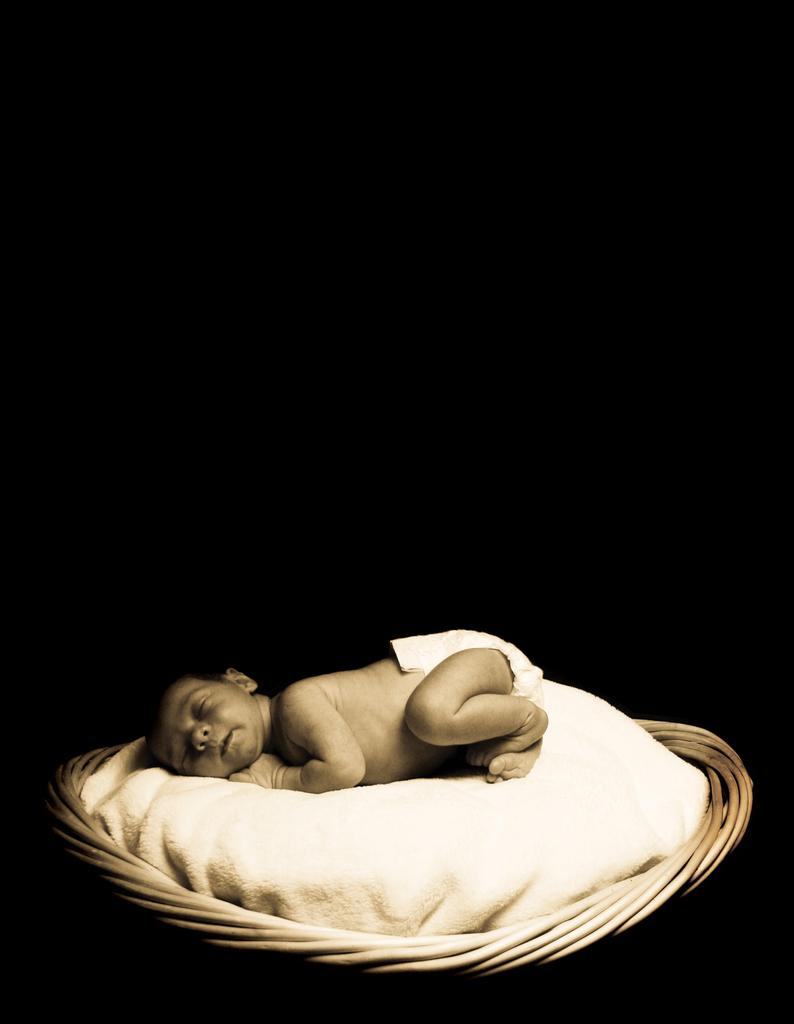What is the main subject of the image? There is a baby lying in the image. What object is present in the image that might be used to hold or carry the baby? There is a cloth in the image that appears to be in the shape of a basket. What can be observed about the background of the image? The background of the image is dark. What type of field can be seen in the background of the image? There is no field present in the image; the background is dark. Can you tell me how many calculators are visible in the image? There are no calculators present in the image. 